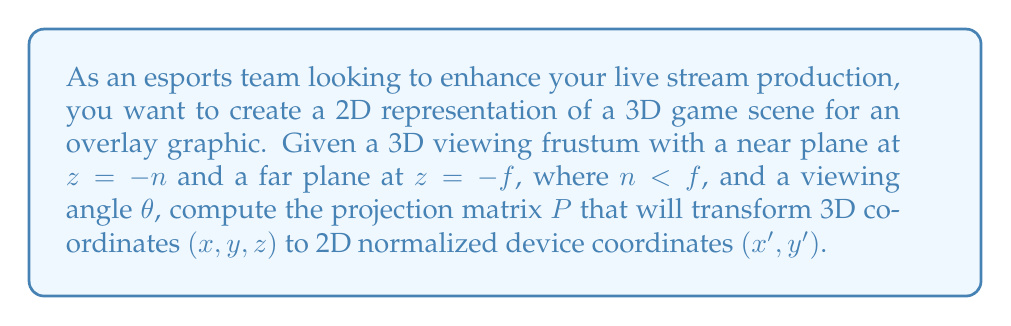Provide a solution to this math problem. To create a 2D representation of a 3D scene, we need to use perspective projection. The projection matrix $P$ will transform 3D coordinates to normalized device coordinates. Let's derive this matrix step by step:

1. First, we need to consider the aspect ratio $a = \frac{width}{height}$ of the viewing window. This affects the x-coordinate scaling.

2. The field of view angle $\theta$ determines the y-coordinate scaling. We can calculate a scaling factor $s = \frac{1}{\tan(\theta/2)}$.

3. For the z-coordinate, we want to map the range $[-n, -f]$ to $[-1, 1]$ in normalized device coordinates.

4. The projection matrix $P$ will have the following form:

   $$P = \begin{bmatrix}
   \frac{s}{a} & 0 & 0 & 0 \\
   0 & s & 0 & 0 \\
   0 & 0 & \frac{f+n}{n-f} & \frac{2fn}{n-f} \\
   0 & 0 & -1 & 0
   \end{bmatrix}$$

5. When this matrix is applied to a 3D point $(x, y, z, 1)$, it results in a 4D vector $(x', y', z', w)$. The final 2D coordinates are obtained by dividing x' and y' by w:

   $$x_{NDC} = \frac{x'}{w} = \frac{sx}{az}, \quad y_{NDC} = \frac{y'}{w} = \frac{sy}{z}$$

This projection preserves the perspective effect, making distant objects appear smaller in the 2D representation.
Answer: The projection matrix $P$ for creating a 2D representation of a 3D scene is:

$$P = \begin{bmatrix}
\frac{1}{a\tan(\theta/2)} & 0 & 0 & 0 \\
0 & \frac{1}{\tan(\theta/2)} & 0 & 0 \\
0 & 0 & \frac{f+n}{n-f} & \frac{2fn}{n-f} \\
0 & 0 & -1 & 0
\end{bmatrix}$$

Where $a$ is the aspect ratio, $\theta$ is the viewing angle, $n$ is the distance to the near plane, and $f$ is the distance to the far plane. 